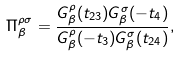Convert formula to latex. <formula><loc_0><loc_0><loc_500><loc_500>\Pi ^ { \rho \sigma } _ { \beta } = \frac { G ^ { \rho } _ { \beta } ( t _ { 2 3 } ) G ^ { \sigma } _ { \beta } ( - t _ { 4 } ) } { G ^ { \rho } _ { \beta } ( - t _ { 3 } ) G ^ { \sigma } _ { \beta } ( t _ { 2 4 } ) } ,</formula> 